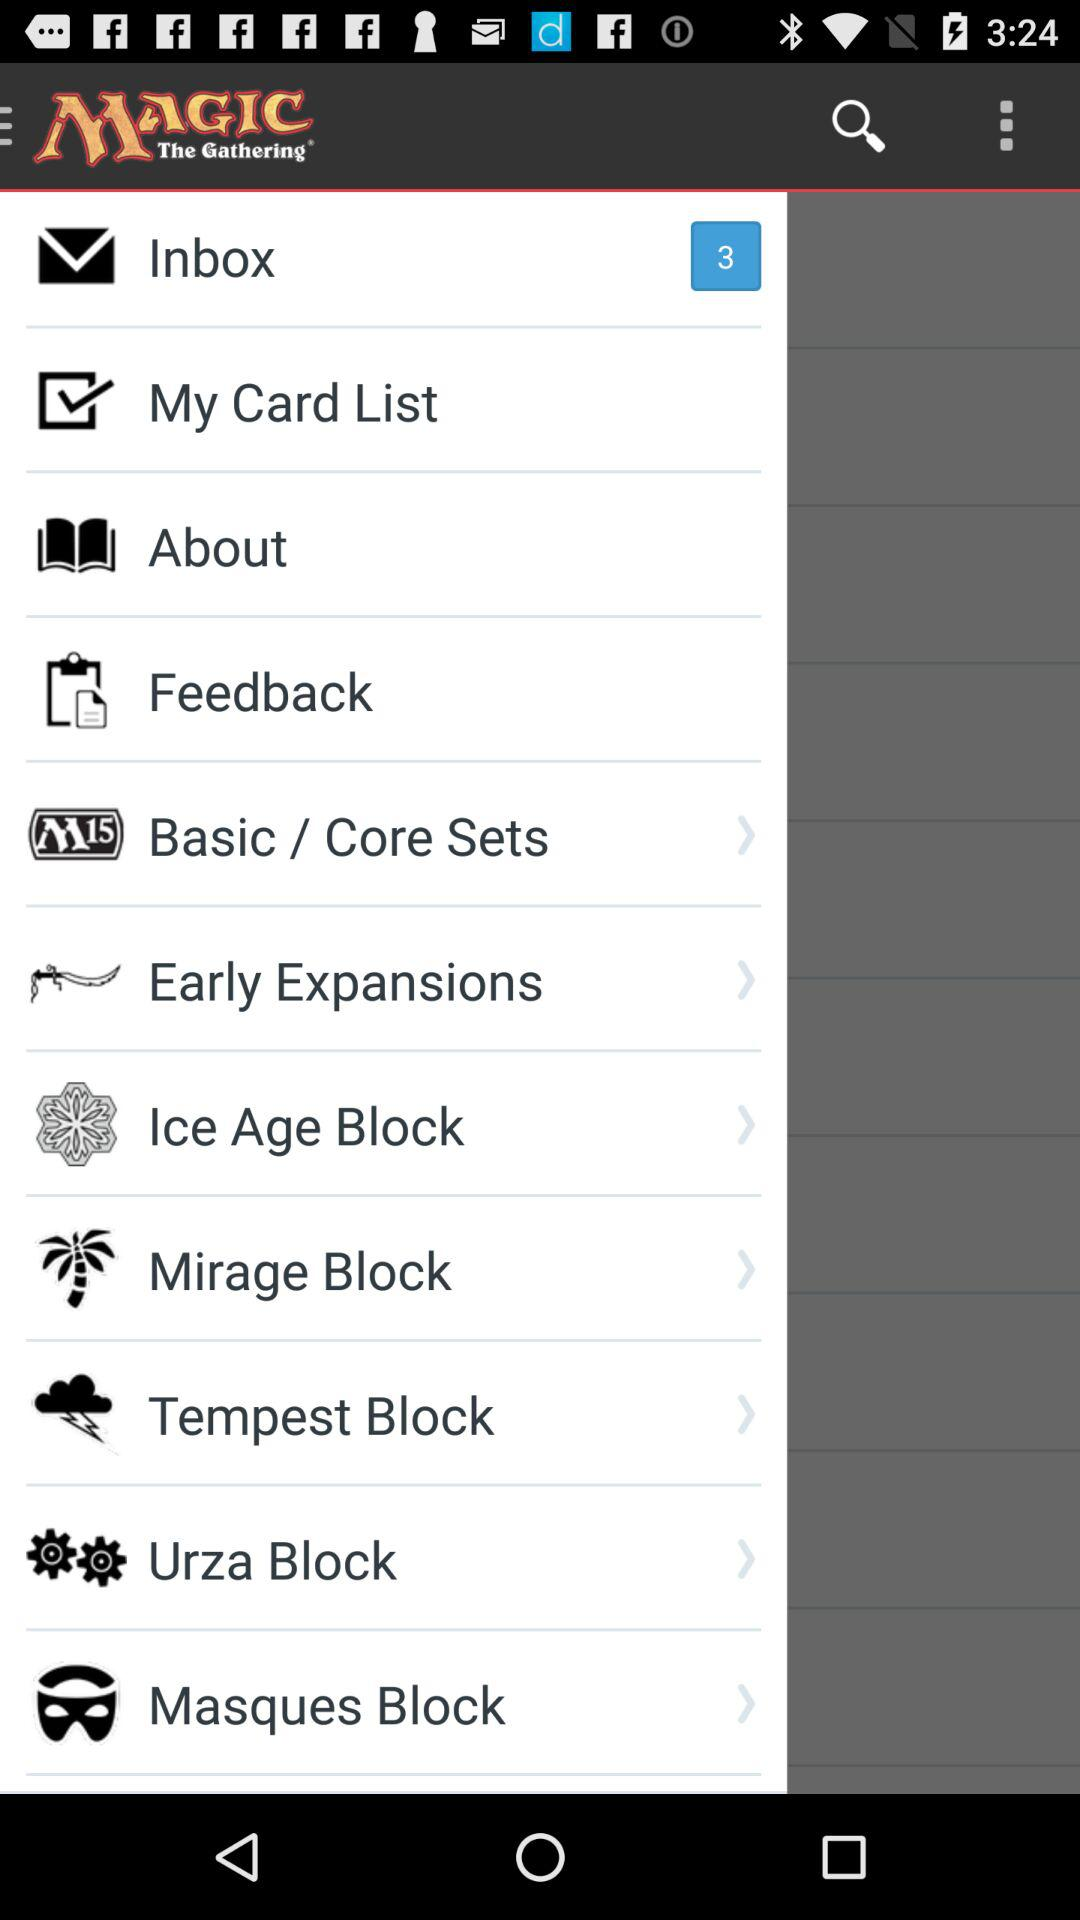How many unread messages are in the inbox? There are 3 unread messages in the inbox. 